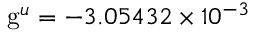<formula> <loc_0><loc_0><loc_500><loc_500>g ^ { u } = - 3 . 0 5 4 3 2 \times 1 0 ^ { - 3 }</formula> 